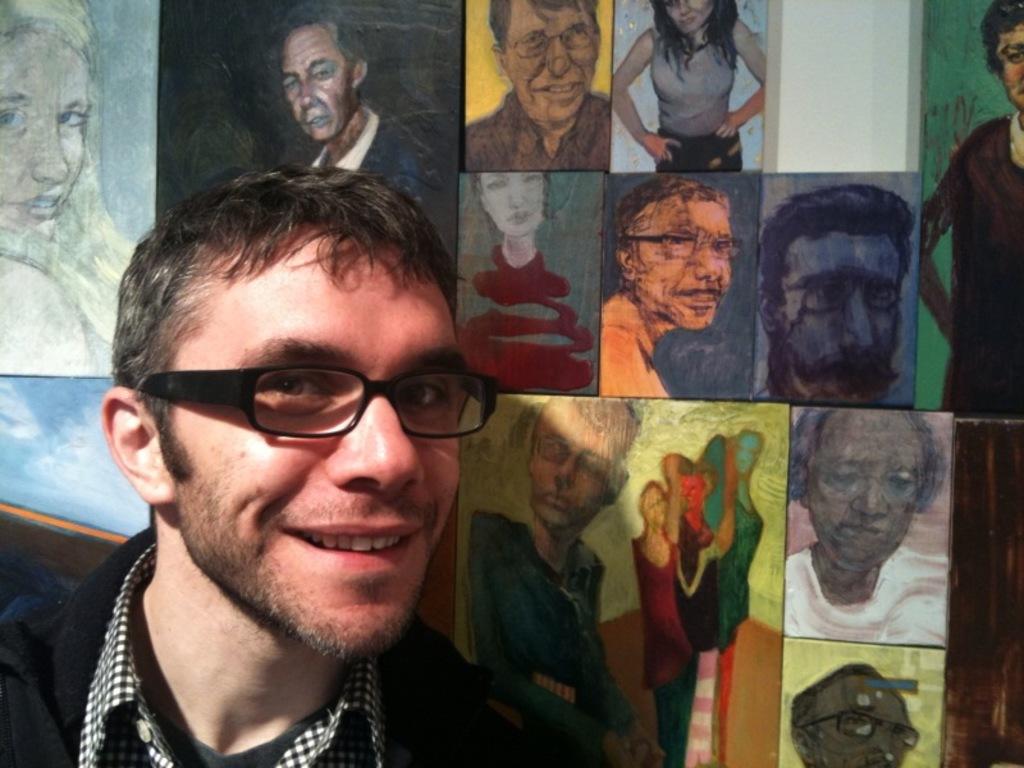Can you describe this image briefly? In this picture I can see a man smiling, there are frames attached to an object. 